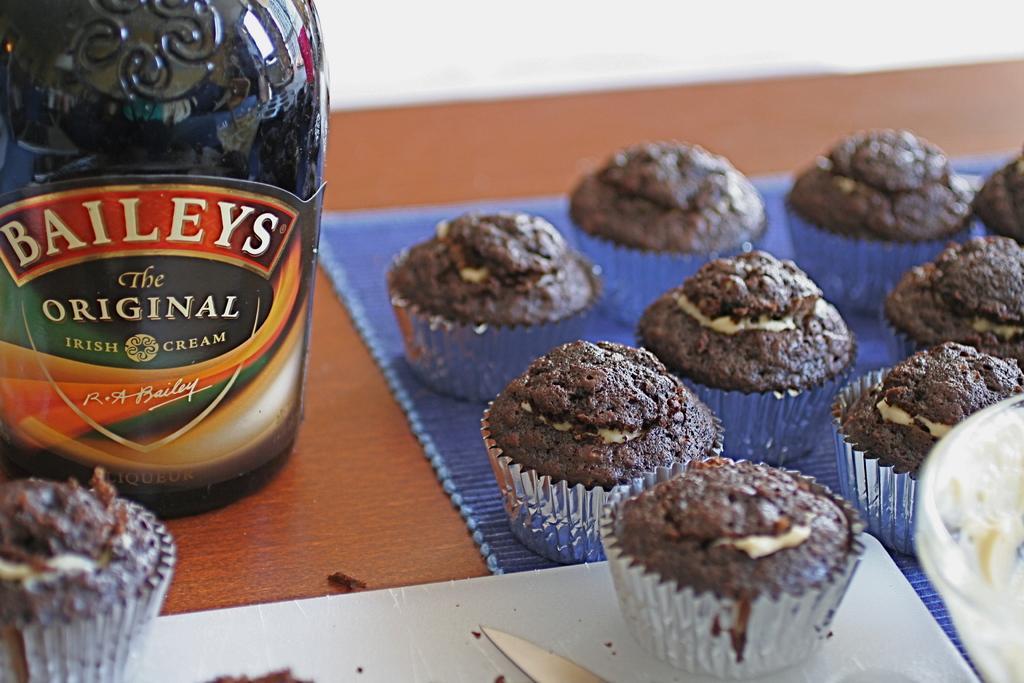Can you describe this image briefly? In this image I can see cupcakes, wine bottle, knife and bowl on a table. 